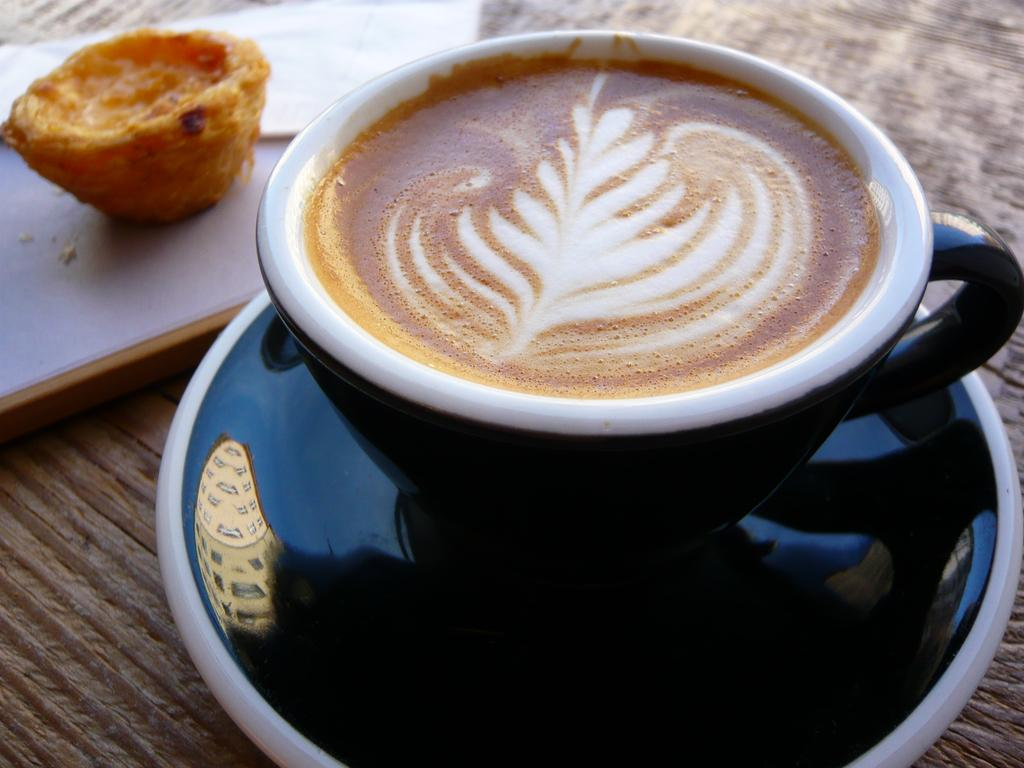What is on the saucer in the image? There is a cup of coffee with a saucer in the image. What else can be seen on the table besides the cup of coffee? There are snacks and tissue papers present in the image. Where are the snacks, cup of coffee, and tissue papers located? The cup of coffee, snacks, and tissue papers are on a table. What type of potato is being used as a body for the snacks in the image? There is no potato present in the image, and the snacks are not depicted as having a body made of a potato. 